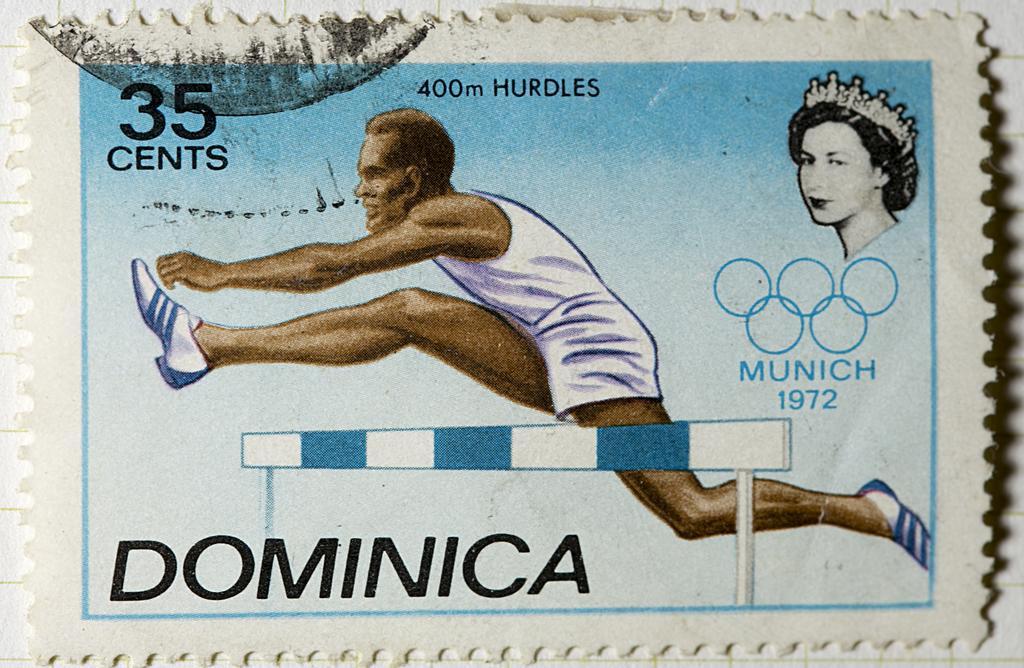In one or two sentences, can you explain what this image depicts? In this picture I can see a stamp on which there are depiction pictures of a man and a woman and I see something is written on it and on the bottom of this stamp I can see a hurdle. 